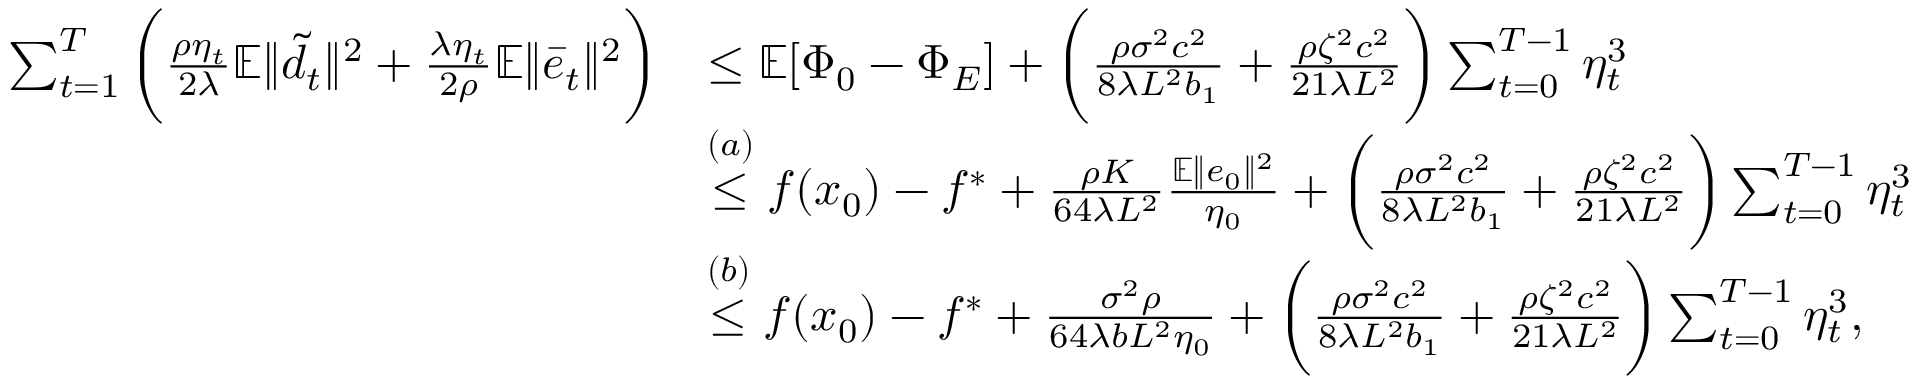<formula> <loc_0><loc_0><loc_500><loc_500>\begin{array} { r l } { \sum _ { t = 1 } ^ { T } \left ( \frac { \rho \eta _ { t } } { 2 \lambda } \mathbb { E } \| \tilde { d } _ { t } \| ^ { 2 } + \frac { \lambda \eta _ { t } } { 2 \rho } \mathbb { E } \| \bar { e } _ { t } \| ^ { 2 } \right ) } & { \leq \mathbb { E } [ \Phi _ { 0 } - \Phi _ { E } ] + \left ( \frac { \rho \sigma ^ { 2 } c ^ { 2 } } { 8 \lambda L ^ { 2 } b _ { 1 } } + \frac { \rho \zeta ^ { 2 } c ^ { 2 } } { 2 1 \lambda L ^ { 2 } } \right ) \sum _ { t = 0 } ^ { T - 1 } \eta _ { t } ^ { 3 } } \\ & { \overset { ( a ) } { \leq } f ( x _ { 0 } ) - f ^ { \ast } + \frac { \rho K } { 6 4 \lambda L ^ { 2 } } \frac { \mathbb { E } \| e _ { 0 } \| ^ { 2 } } { \eta _ { 0 } } + \left ( \frac { \rho \sigma ^ { 2 } c ^ { 2 } } { 8 \lambda L ^ { 2 } b _ { 1 } } + \frac { \rho \zeta ^ { 2 } c ^ { 2 } } { 2 1 \lambda L ^ { 2 } } \right ) \sum _ { t = 0 } ^ { T - 1 } \eta _ { t } ^ { 3 } } \\ & { \overset { ( b ) } { \leq } f ( x _ { 0 } ) - f ^ { \ast } + \frac { \sigma ^ { 2 } \rho } { 6 4 \lambda b L ^ { 2 } \eta _ { 0 } } + \left ( \frac { \rho \sigma ^ { 2 } c ^ { 2 } } { 8 \lambda L ^ { 2 } b _ { 1 } } + \frac { \rho \zeta ^ { 2 } c ^ { 2 } } { 2 1 \lambda L ^ { 2 } } \right ) \sum _ { t = 0 } ^ { T - 1 } \eta _ { t } ^ { 3 } , } \end{array}</formula> 